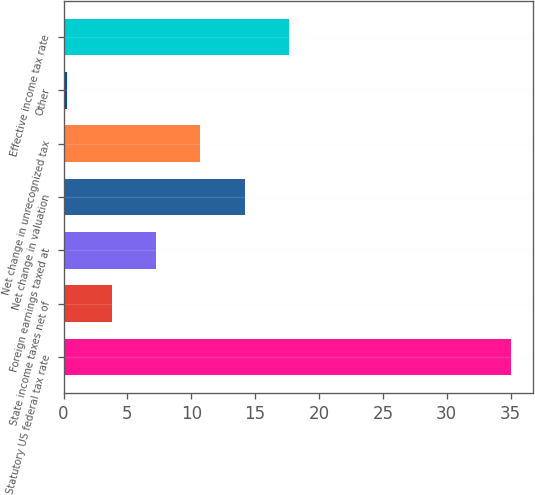<chart> <loc_0><loc_0><loc_500><loc_500><bar_chart><fcel>Statutory US federal tax rate<fcel>State income taxes net of<fcel>Foreign earnings taxed at<fcel>Net change in valuation<fcel>Net change in unrecognized tax<fcel>Other<fcel>Effective income tax rate<nl><fcel>35<fcel>3.77<fcel>7.24<fcel>14.18<fcel>10.71<fcel>0.3<fcel>17.65<nl></chart> 